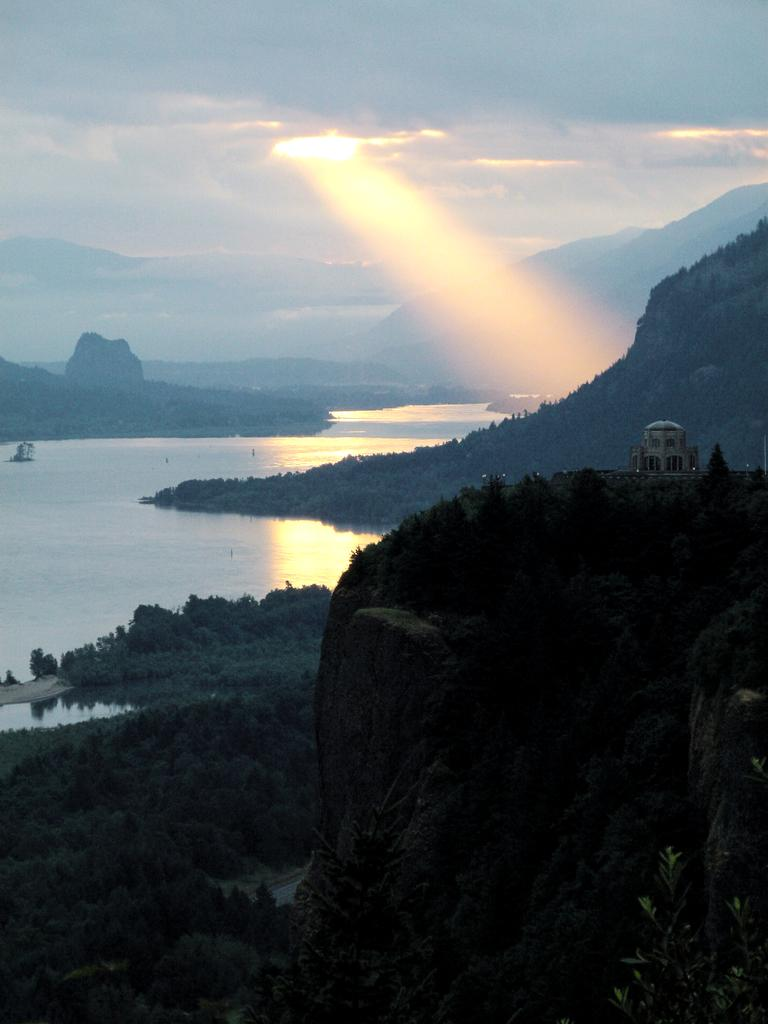What type of natural environment is depicted in the image? The image contains trees, water, hills, and clouds, which suggest a natural landscape. Can you describe the water in the image? There is water visible in the image, but its specific characteristics are not mentioned in the facts. What is the location of the building in the image? The building is on the right side of the image. What type of wool is being used to create the fog in the image? There is no fog or wool present in the image; it features a natural landscape with trees, water, hills, clouds, and a building. 